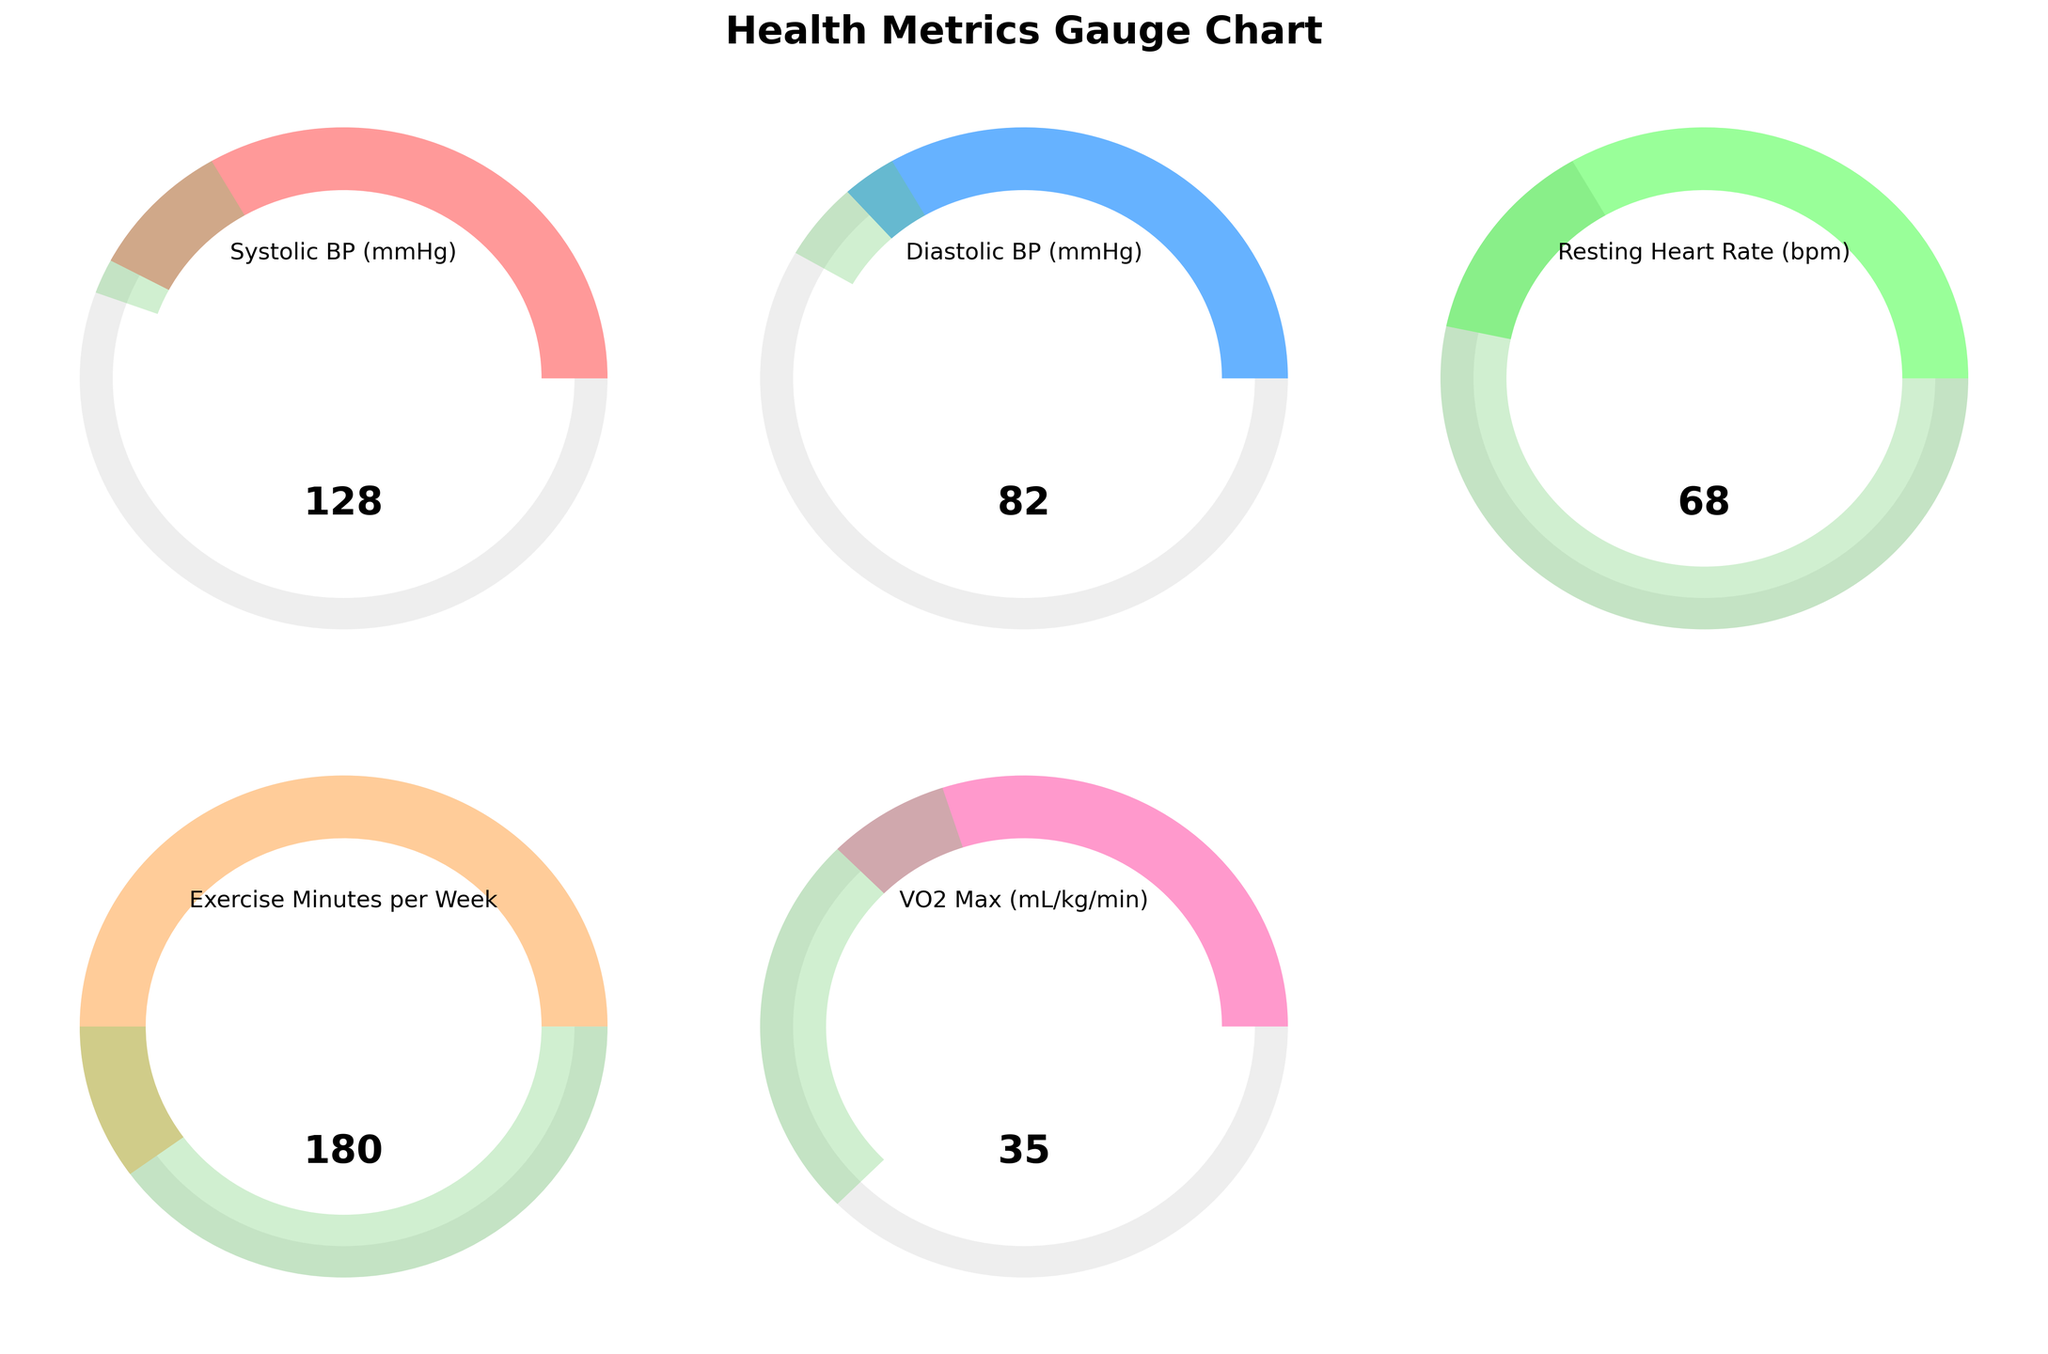What is the highest measured value displayed on the gauge charts? The highest measured value displayed is for "Exercise Minutes per Week" with a value of 180. This can be observed by looking at the highest value in each gauge chart.
Answer: 180 What is the target range for Systolic BP (mmHg)? The target range for Systolic BP (mmHg) is between 120 and 130 mmHg. This information is provided in the data and is visually represented as the green segment on the Systolic BP gauge.
Answer: 120-130 How much higher is the current Systolic BP compared to its target minimum? The current Systolic BP is 128 mmHg, and the target minimum is 120 mmHg. The difference is calculated as 128 - 120 = 8 mmHg.
Answer: 8 mmHg Which metric is within its target range? The metric "Resting Heart Rate (bpm)" is within its target range, as it has a value of 68 bpm, and the target range is between 60 and 100 bpm. This can be observed by looking at the gauge chart for Resting Heart Rate.
Answer: Resting Heart Rate (bpm) What is the average value of Diastolic BP and Resting Heart Rate? The Diastolic BP is 82 mmHg and the Resting Heart Rate is 68 bpm. The average is calculated as (82 + 68) / 2 = 75.
Answer: 75 Is the current VO2 Max within the target range? The current VO2 Max is 35 mL/kg/min, and the target range is between 32 and 45 mL/kg/min. Since 35 falls within this range, it is within the target range.
Answer: Yes Which metric is closest to its maximum allowable value? The metric "Diastolic BP (mmHg)" is closest to its maximum allowable value, with a measured value of 82 mmHg and a maximum allowable value of 120 mmHg. To determine this, we calculate the proximity to the maximum value for each metric.
Answer: Diastolic BP (mmHg) What proportion of the target range does the measured Systolic BP fall into for its gauge chart? The measured Systolic BP is 128 mmHg. The target range is from 120 to 130 mmHg. The proportion of the target range covered can be calculated as (128 - 120) / (130 - 120) = 0.8, or 80%.
Answer: 80% By how much does the current Exercise Minutes per Week exceed the minimum target? The current value for Exercise Minutes per Week is 180 minutes, and the minimum target is 150 minutes. The difference is 180 - 150 = 30 minutes.
Answer: 30 minutes How does the measured Resting Heart Rate compare to the rest of the metrics in the context of their healthy ranges? The measured Resting Heart Rate of 68 bpm is comfortably within its target range of 60-100 bpm, unlike the Systolic and Diastolic BP, which are closer to the boundaries of their target ranges or outside it.
Answer: Within range 